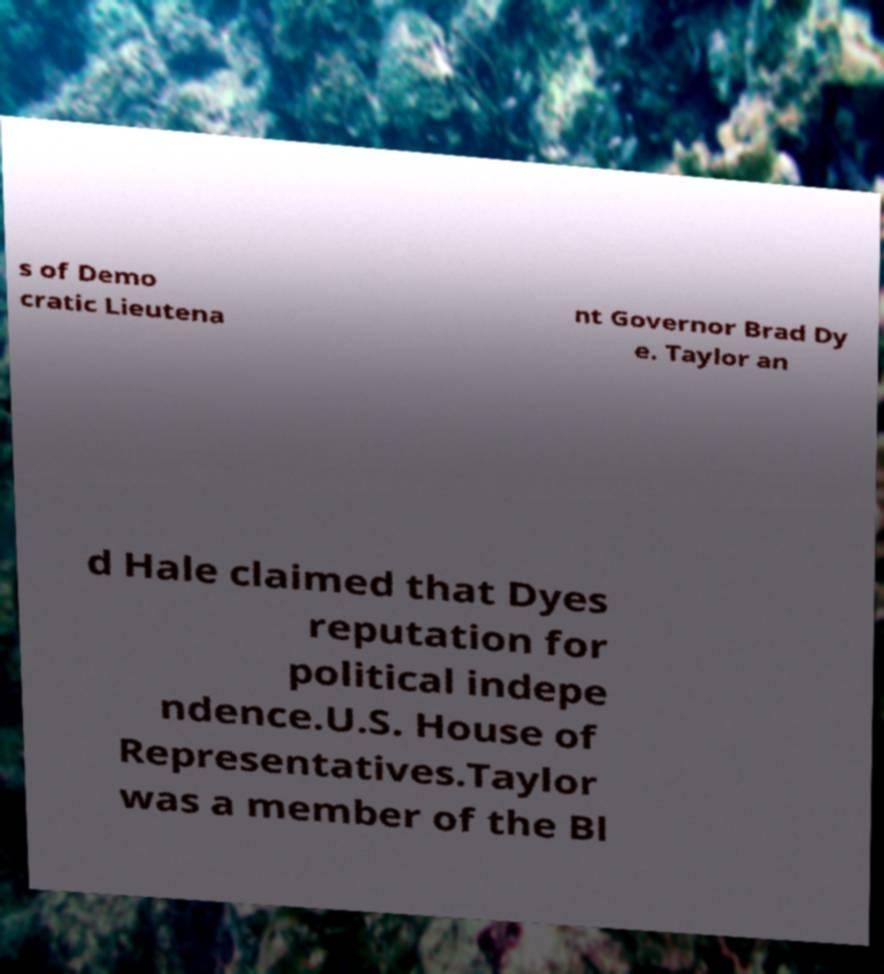For documentation purposes, I need the text within this image transcribed. Could you provide that? s of Demo cratic Lieutena nt Governor Brad Dy e. Taylor an d Hale claimed that Dyes reputation for political indepe ndence.U.S. House of Representatives.Taylor was a member of the Bl 